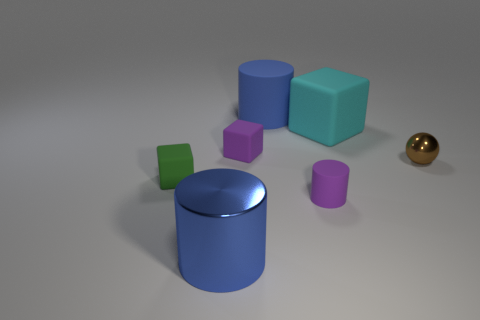Subtract all gray cubes. Subtract all yellow cylinders. How many cubes are left? 3 Add 1 tiny purple balls. How many objects exist? 8 Subtract all spheres. How many objects are left? 6 Subtract all big blue metal things. Subtract all big brown matte cylinders. How many objects are left? 6 Add 4 blue metallic things. How many blue metallic things are left? 5 Add 4 big blue matte things. How many big blue matte things exist? 5 Subtract 1 purple cylinders. How many objects are left? 6 